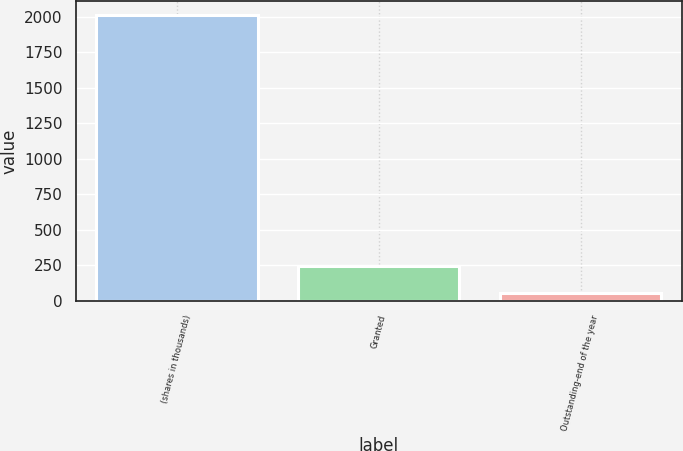Convert chart. <chart><loc_0><loc_0><loc_500><loc_500><bar_chart><fcel>(shares in thousands)<fcel>Granted<fcel>Outstanding-end of the year<nl><fcel>2013<fcel>247.86<fcel>51.73<nl></chart> 